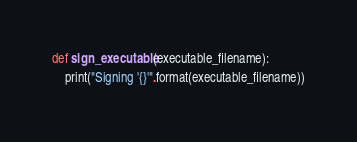Convert code to text. <code><loc_0><loc_0><loc_500><loc_500><_Python_>
def sign_executable(executable_filename):
    print("Signing '{}'".format(executable_filename))
</code> 